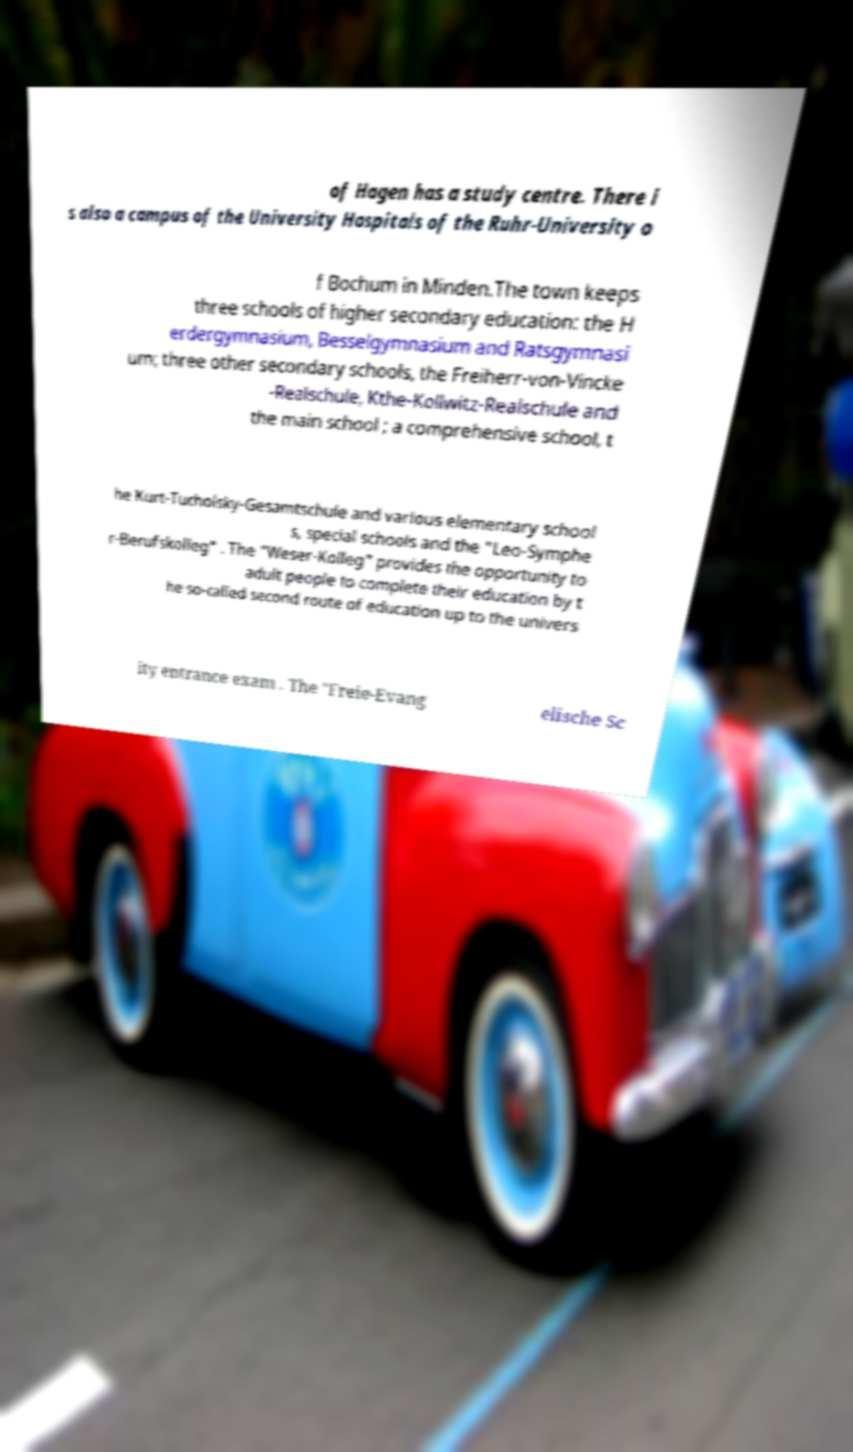For documentation purposes, I need the text within this image transcribed. Could you provide that? of Hagen has a study centre. There i s also a campus of the University Hospitals of the Ruhr-University o f Bochum in Minden.The town keeps three schools of higher secondary education: the H erdergymnasium, Besselgymnasium and Ratsgymnasi um; three other secondary schools, the Freiherr-von-Vincke -Realschule, Kthe-Kollwitz-Realschule and the main school ; a comprehensive school, t he Kurt-Tucholsky-Gesamtschule and various elementary school s, special schools and the "Leo-Symphe r-Berufskolleg" . The "Weser-Kolleg" provides the opportunity to adult people to complete their education by t he so-called second route of education up to the univers ity entrance exam . The "Freie-Evang elische Sc 